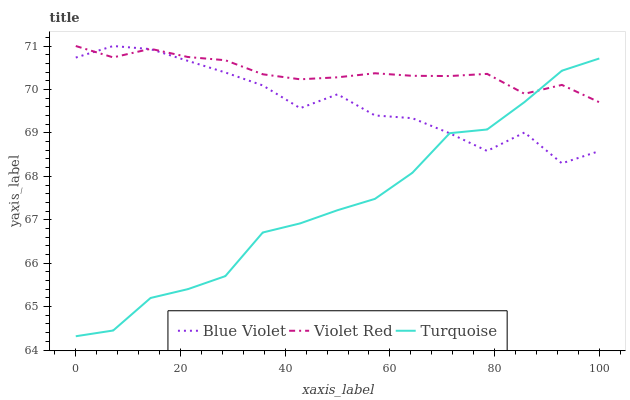Does Turquoise have the minimum area under the curve?
Answer yes or no. Yes. Does Violet Red have the maximum area under the curve?
Answer yes or no. Yes. Does Blue Violet have the minimum area under the curve?
Answer yes or no. No. Does Blue Violet have the maximum area under the curve?
Answer yes or no. No. Is Violet Red the smoothest?
Answer yes or no. Yes. Is Blue Violet the roughest?
Answer yes or no. Yes. Is Turquoise the smoothest?
Answer yes or no. No. Is Turquoise the roughest?
Answer yes or no. No. Does Turquoise have the lowest value?
Answer yes or no. Yes. Does Blue Violet have the lowest value?
Answer yes or no. No. Does Blue Violet have the highest value?
Answer yes or no. Yes. Does Turquoise have the highest value?
Answer yes or no. No. Does Blue Violet intersect Violet Red?
Answer yes or no. Yes. Is Blue Violet less than Violet Red?
Answer yes or no. No. Is Blue Violet greater than Violet Red?
Answer yes or no. No. 